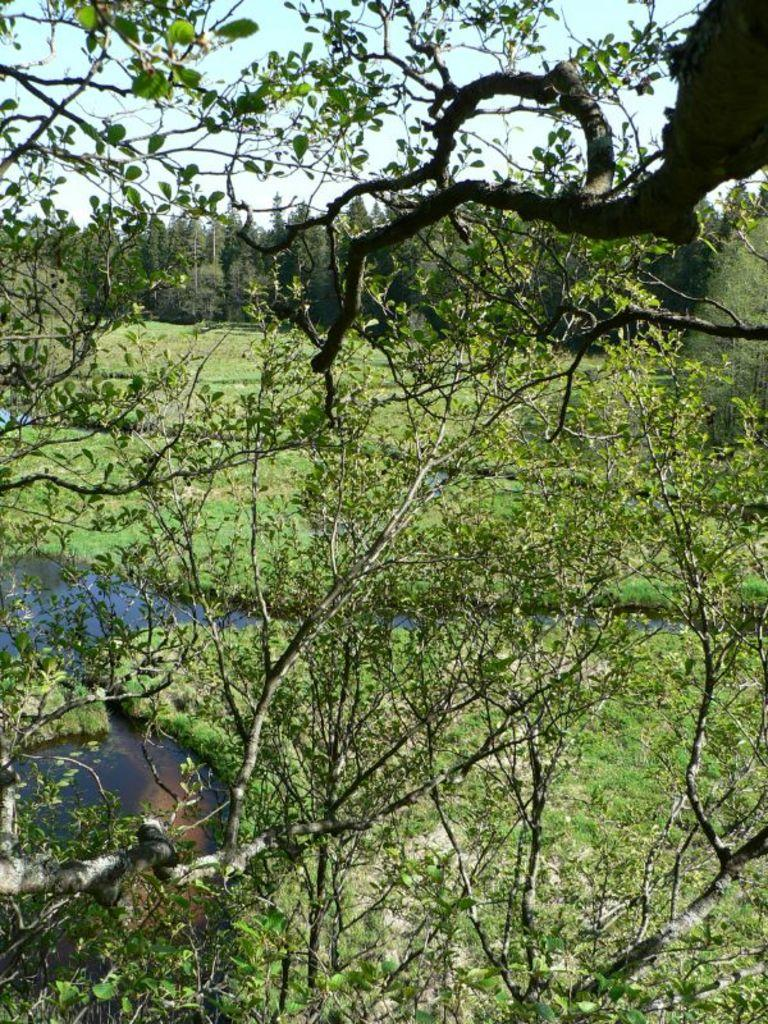What type of vegetation is in the front of the image? There are leaves in the front of the image. What type of vegetation is on the ground in the background of the image? There is grass on the ground in the background of the image. What can be seen in the background of the image besides grass? There is water and trees visible in the background of the image. What type of scent can be smelled coming from the toys in the image? There are no toys present in the image, so it is not possible to determine what scent might be associated with them. 